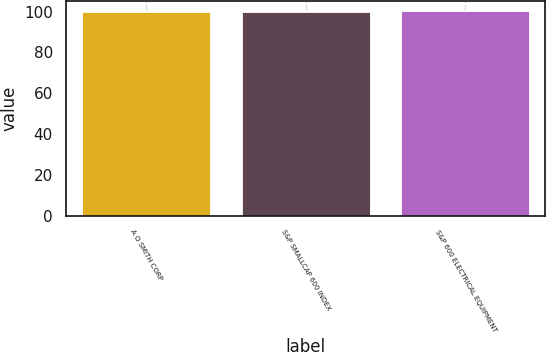<chart> <loc_0><loc_0><loc_500><loc_500><bar_chart><fcel>A O SMITH CORP<fcel>S&P SMALLCAP 600 INDEX<fcel>S&P 600 ELECTRICAL EQUIPMENT<nl><fcel>100<fcel>100.1<fcel>100.2<nl></chart> 